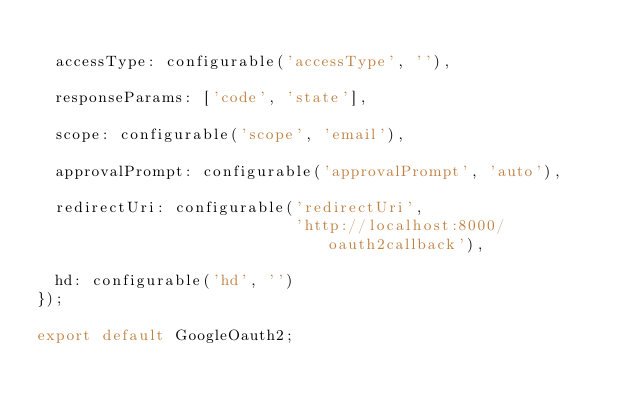Convert code to text. <code><loc_0><loc_0><loc_500><loc_500><_JavaScript_>
  accessType: configurable('accessType', ''),

  responseParams: ['code', 'state'],

  scope: configurable('scope', 'email'),

  approvalPrompt: configurable('approvalPrompt', 'auto'),

  redirectUri: configurable('redirectUri',
                            'http://localhost:8000/oauth2callback'),

  hd: configurable('hd', '')
});

export default GoogleOauth2;
</code> 